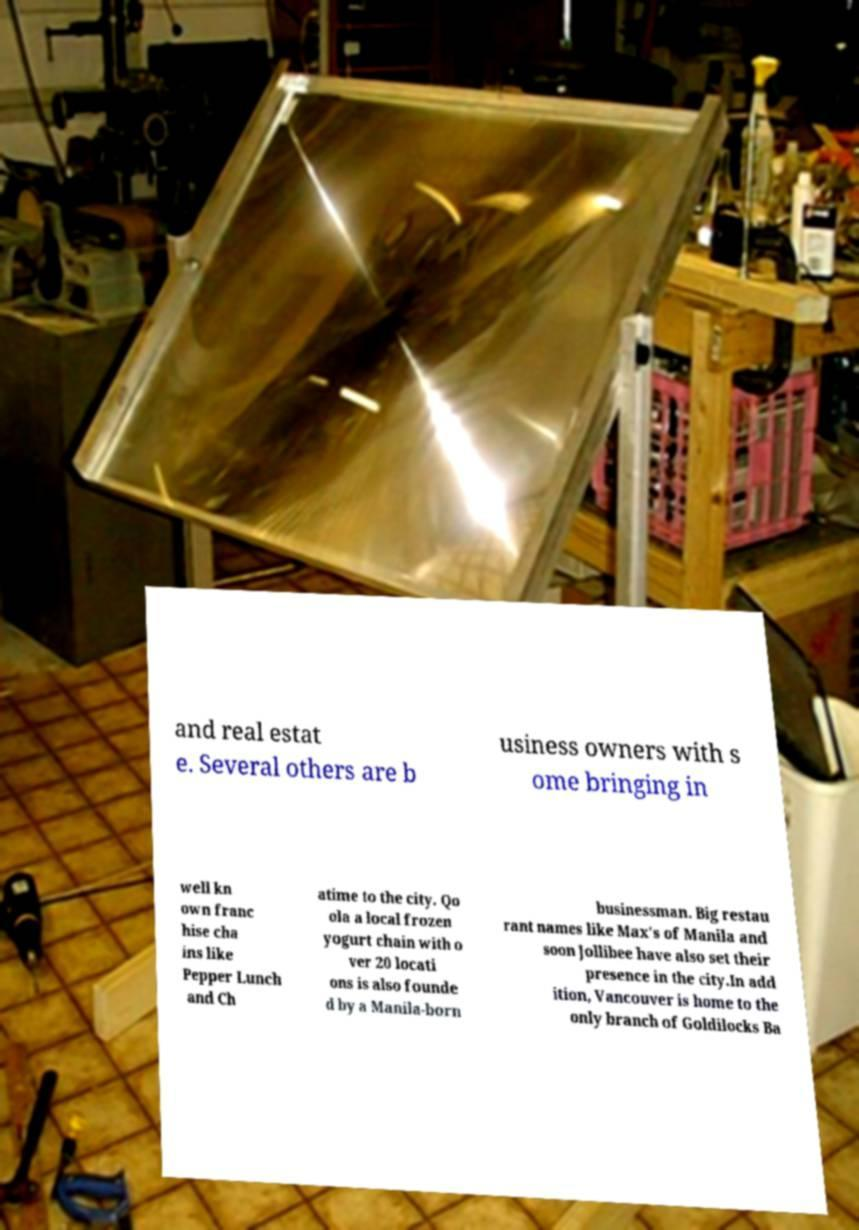I need the written content from this picture converted into text. Can you do that? and real estat e. Several others are b usiness owners with s ome bringing in well kn own franc hise cha ins like Pepper Lunch and Ch atime to the city. Qo ola a local frozen yogurt chain with o ver 20 locati ons is also founde d by a Manila-born businessman. Big restau rant names like Max's of Manila and soon Jollibee have also set their presence in the city.In add ition, Vancouver is home to the only branch of Goldilocks Ba 